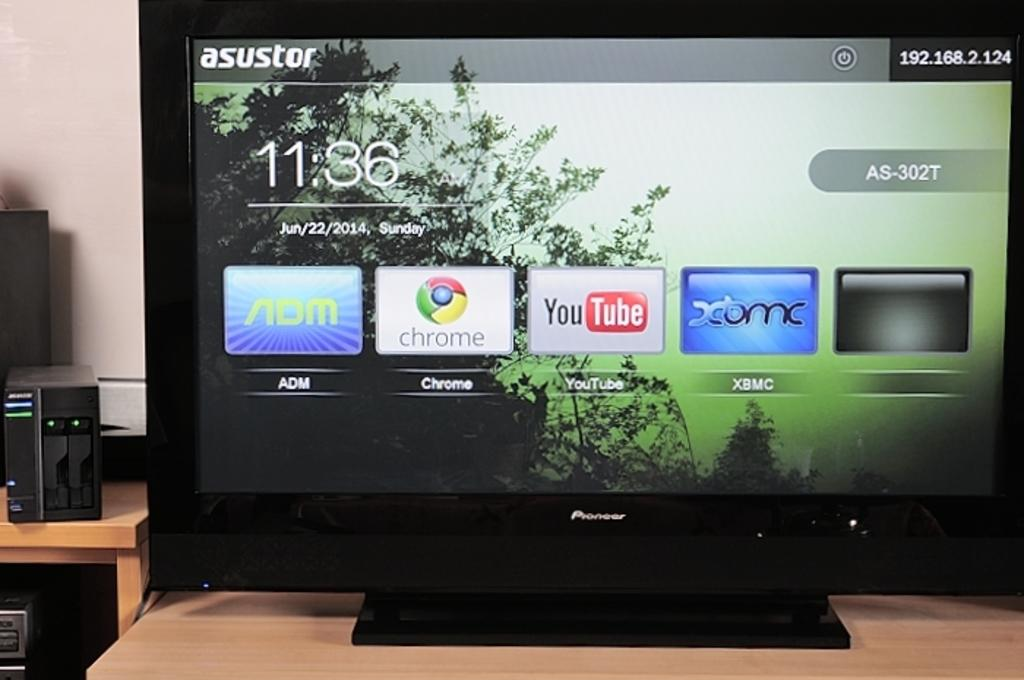<image>
Offer a succinct explanation of the picture presented. A Pioneer TV is showing a screen with apps such as YouTube and Chrome. 